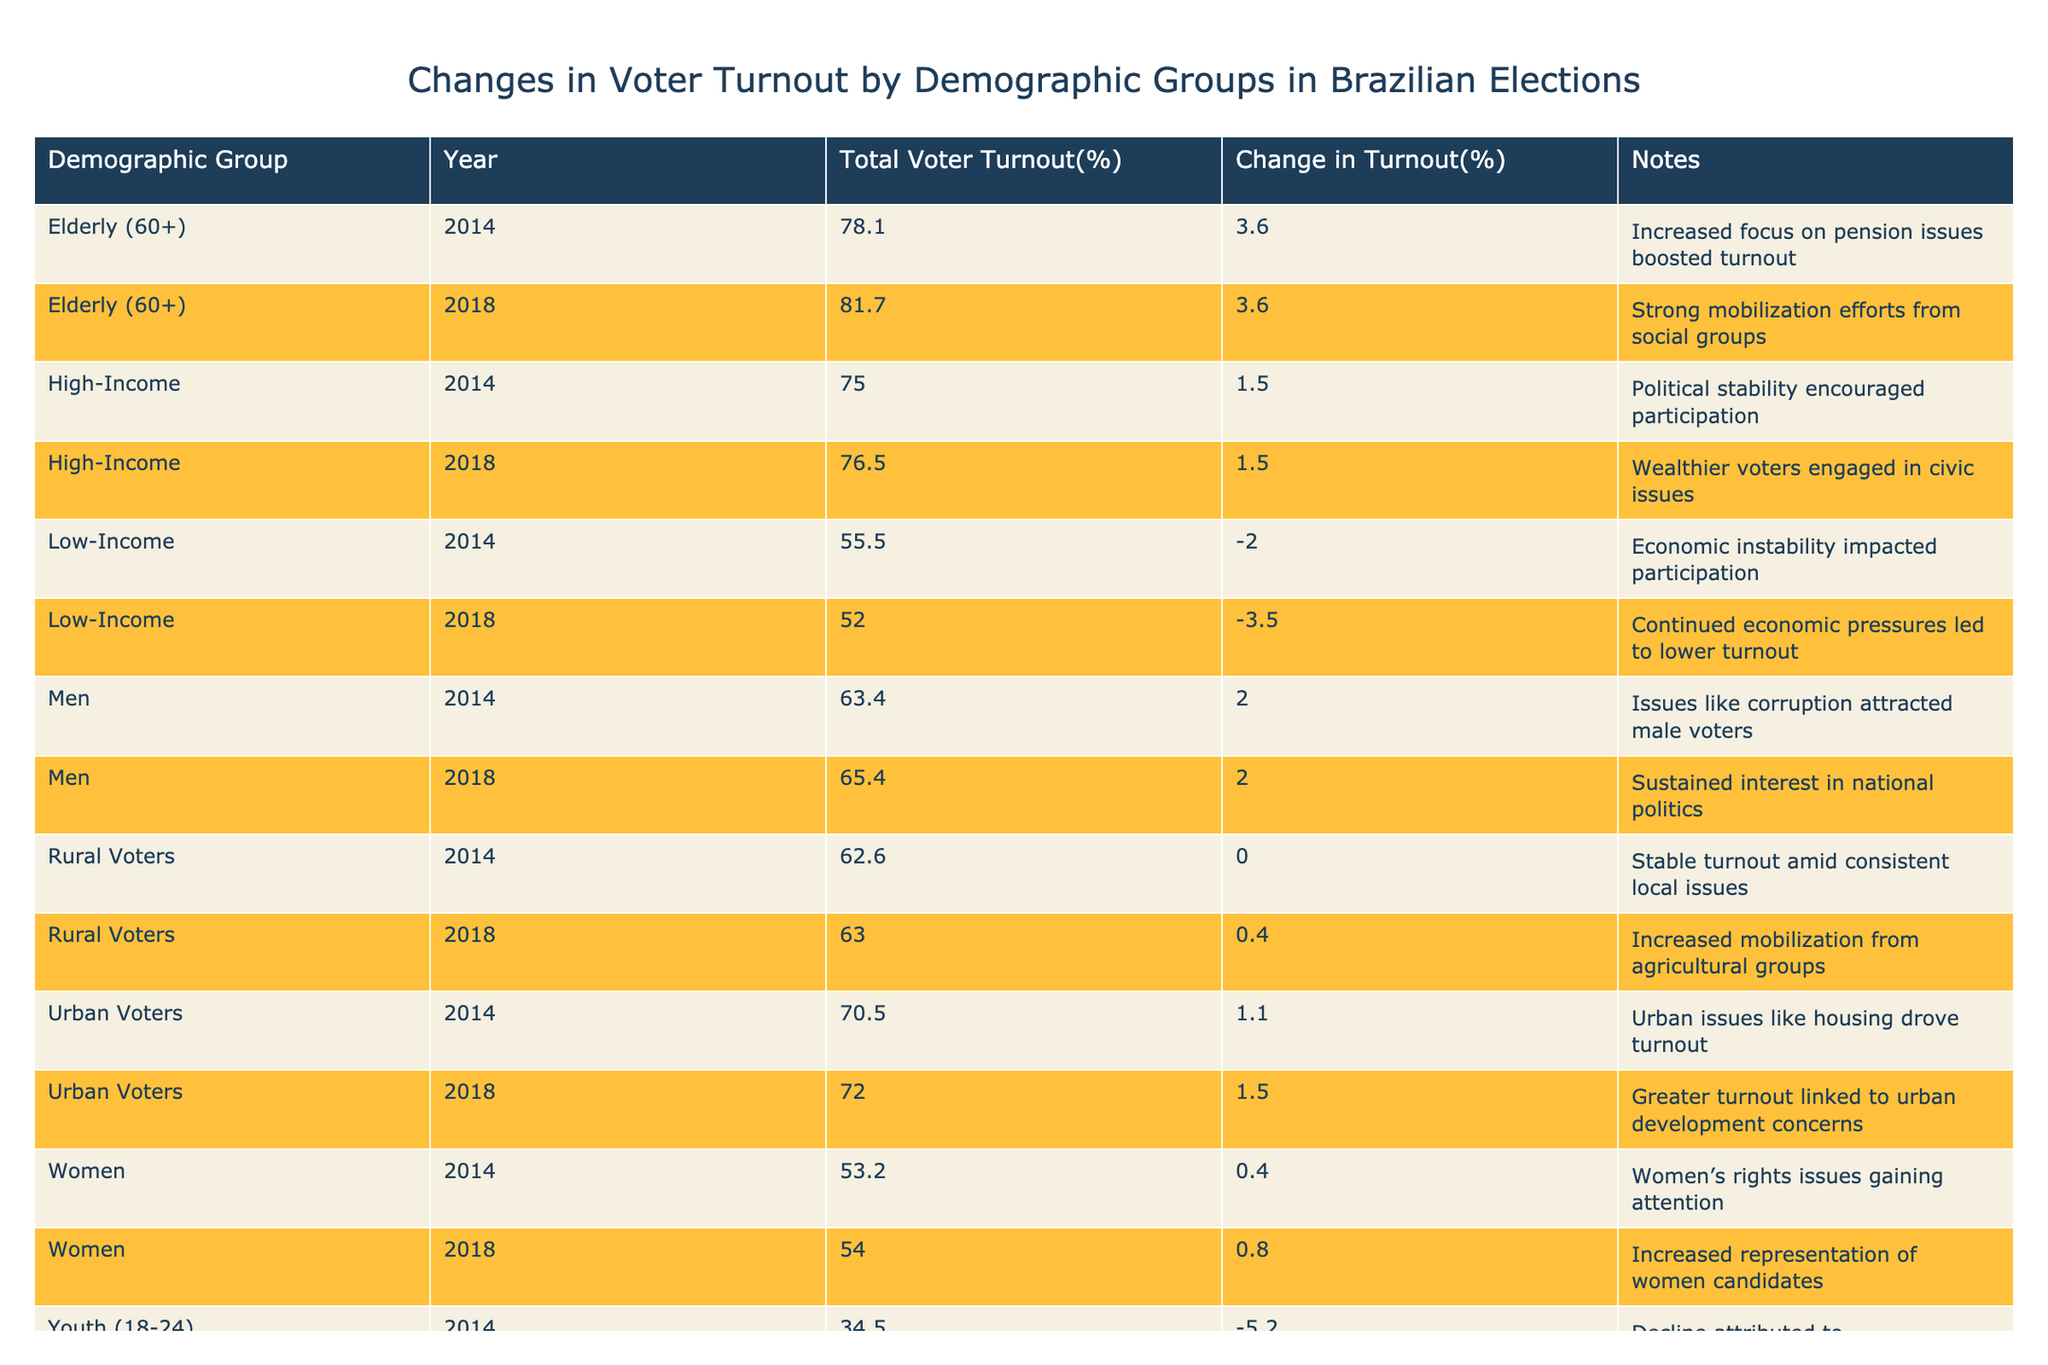What was the total voter turnout percentage for Youth (18-24) in 2014? According to the table, the total voter turnout percentage for Youth (18-24) in 2014 is listed directly. It states 34.5%.
Answer: 34.5% What was the change in voter turnout for Women from 2014 to 2018? To find this, we subtract the 2014 turnout (53.2%) from the 2018 turnout (54.0%). Thus, 54.0% - 53.2% = 0.8%.
Answer: 0.8% Did voter turnout for Low-Income individuals increase from 2014 to 2018? Looking at the table, the turnout for Low-Income was 55.5% in 2014 and dropped to 52.0% in 2018, indicating a decrease in turnout. Therefore, the answer is no.
Answer: No What was the average voter turnout percentage for Elderly (60+) over the years included in the table? We can find the average by adding the two years of turnout (78.1% in 2014 and 81.7% in 2018) and then dividing by 2: (78.1% + 81.7%) / 2 = 79.9%.
Answer: 79.9% Which demographic group experienced the highest decline in voter turnout from 2014 to 2018? To find this, we compare the changes in turnout for each demographic group, which are: Youth (-5.2%), Low-Income (-3.5%), and others. The highest decline is for Youth at -5.2%.
Answer: Youth (18-24) What was the voter turnout percentage for Urban Voters in 2018? The table shows that the voter turnout percentage for Urban Voters in 2018 is explicitly listed as 72.0%.
Answer: 72.0% Was there an increase in voter turnout for High-Income individuals from 2014 to 2018? High-Income turnout was 75.0% in 2014 and increased to 76.5% in 2018, indicating that there was indeed an increase. Thus, the answer is yes.
Answer: Yes What is the difference in voter turnout for Rural Voters between the years 2014 and 2018? The turnout for Rural Voters was 62.6% in 2014 and increased to 63.0% in 2018. Therefore, the difference is 63.0% - 62.6% = 0.4%.
Answer: 0.4% How did the turnout for Men change from 2014 to 2018? The turnout for Men in 2014 was 63.4% and in 2018 it was 65.4%. To find the change, we calculate 65.4% - 63.4% = 2.0%, indicating an increase.
Answer: 2.0% 